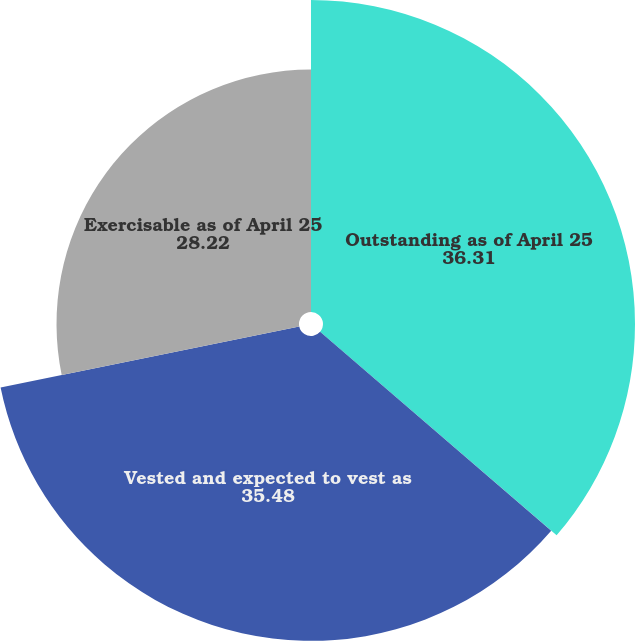<chart> <loc_0><loc_0><loc_500><loc_500><pie_chart><fcel>Outstanding as of April 25<fcel>Vested and expected to vest as<fcel>Exercisable as of April 25<nl><fcel>36.31%<fcel>35.48%<fcel>28.22%<nl></chart> 